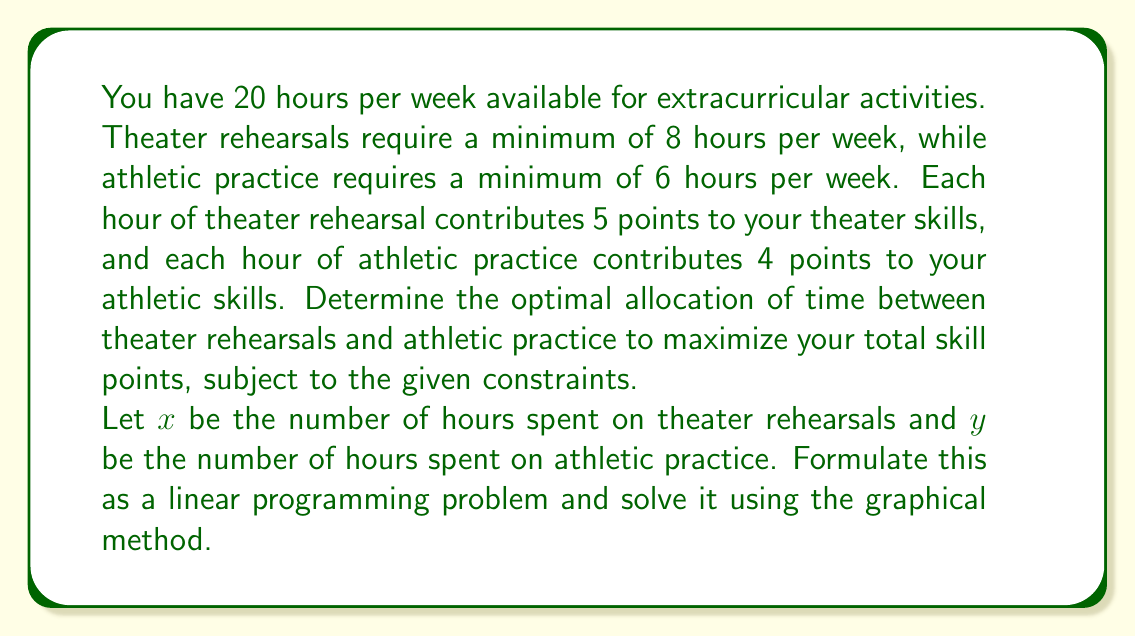What is the answer to this math problem? 1. Formulate the linear programming problem:
   Maximize: $Z = 5x + 4y$ (total skill points)
   Subject to:
   $x \geq 8$ (minimum theater hours)
   $y \geq 6$ (minimum athletic hours)
   $x + y \leq 20$ (total available hours)
   $x, y \geq 0$ (non-negativity constraints)

2. Plot the constraints:
   [asy]
   import graph;
   size(200);
   xaxis("x (Theater hours)", 0, 22, Arrow);
   yaxis("y (Athletic hours)", 0, 22, Arrow);
   draw((8,0)--(8,14)--(0,20), blue);
   draw((0,6)--(14,6), blue);
   draw((0,20)--(20,0), red);
   label("x = 8", (8,7), W);
   label("y = 6", (7,6), S);
   label("x + y = 20", (10,10), NW);
   fill((8,6)--(8,12)--(12,8)--(14,6)--cycle, palegreen);
   [/asy]

3. Identify the feasible region (shaded in green).

4. Find the corner points of the feasible region:
   A(8, 6), B(8, 12), C(12, 8), D(14, 6)

5. Evaluate the objective function at each corner point:
   A: $Z = 5(8) + 4(6) = 64$
   B: $Z = 5(8) + 4(12) = 88$
   C: $Z = 5(12) + 4(8) = 92$
   D: $Z = 5(14) + 4(6) = 94$

6. The maximum value occurs at point D(14, 6), which represents 14 hours of theater rehearsals and 6 hours of athletic practice.
Answer: 14 hours theater, 6 hours athletics 